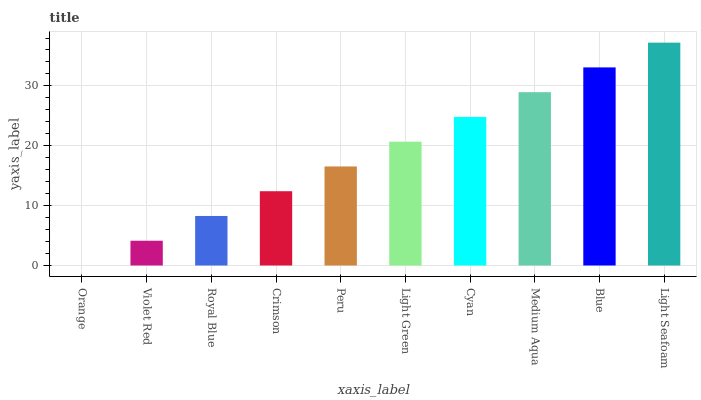Is Violet Red the minimum?
Answer yes or no. No. Is Violet Red the maximum?
Answer yes or no. No. Is Violet Red greater than Orange?
Answer yes or no. Yes. Is Orange less than Violet Red?
Answer yes or no. Yes. Is Orange greater than Violet Red?
Answer yes or no. No. Is Violet Red less than Orange?
Answer yes or no. No. Is Light Green the high median?
Answer yes or no. Yes. Is Peru the low median?
Answer yes or no. Yes. Is Light Seafoam the high median?
Answer yes or no. No. Is Cyan the low median?
Answer yes or no. No. 